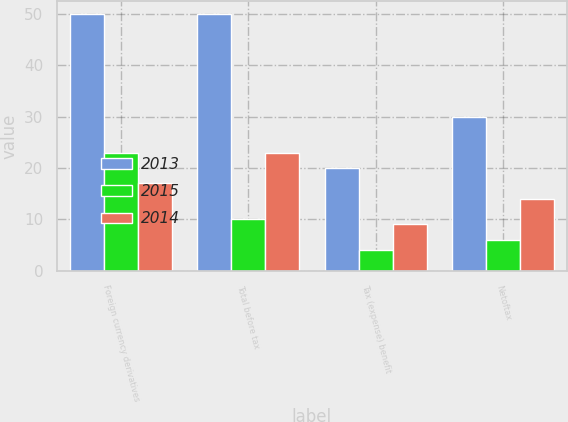Convert chart. <chart><loc_0><loc_0><loc_500><loc_500><stacked_bar_chart><ecel><fcel>Foreign currency derivatives<fcel>Total before tax<fcel>Tax (expense) benefit<fcel>Netoftax<nl><fcel>2013<fcel>50<fcel>50<fcel>20<fcel>30<nl><fcel>2015<fcel>23<fcel>10<fcel>4<fcel>6<nl><fcel>2014<fcel>17<fcel>23<fcel>9<fcel>14<nl></chart> 